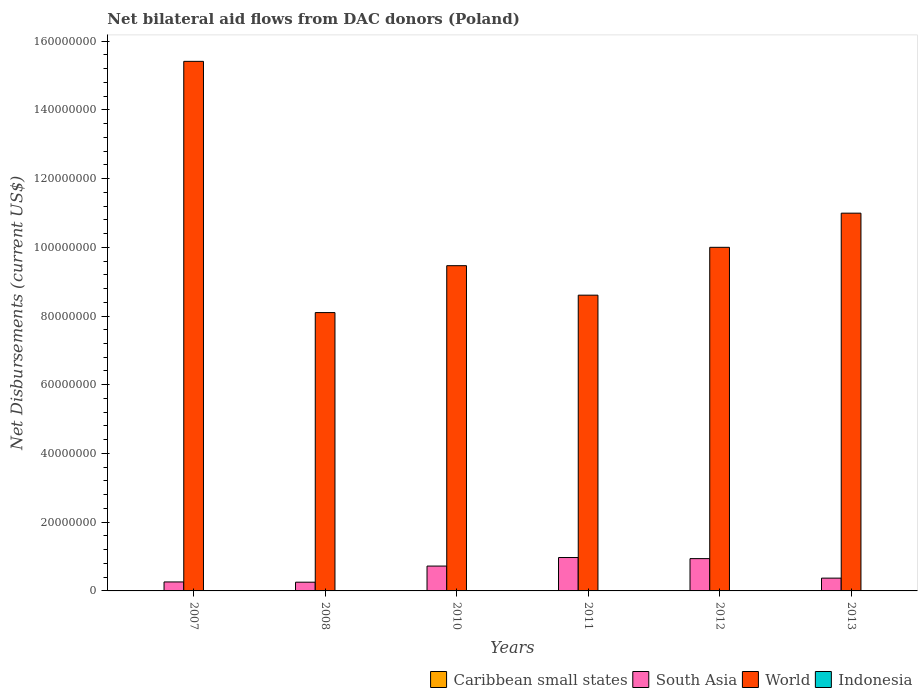How many different coloured bars are there?
Provide a short and direct response. 4. How many groups of bars are there?
Your answer should be compact. 6. What is the label of the 6th group of bars from the left?
Provide a short and direct response. 2013. What is the net bilateral aid flows in Indonesia in 2012?
Offer a terse response. 3.00e+04. Across all years, what is the minimum net bilateral aid flows in South Asia?
Your response must be concise. 2.54e+06. In which year was the net bilateral aid flows in World maximum?
Make the answer very short. 2007. In which year was the net bilateral aid flows in South Asia minimum?
Your answer should be compact. 2008. What is the total net bilateral aid flows in Indonesia in the graph?
Your answer should be compact. 2.70e+05. What is the difference between the net bilateral aid flows in World in 2008 and that in 2013?
Provide a succinct answer. -2.89e+07. What is the difference between the net bilateral aid flows in South Asia in 2011 and the net bilateral aid flows in Indonesia in 2010?
Keep it short and to the point. 9.71e+06. What is the average net bilateral aid flows in South Asia per year?
Your answer should be compact. 5.87e+06. In the year 2008, what is the difference between the net bilateral aid flows in South Asia and net bilateral aid flows in World?
Ensure brevity in your answer.  -7.85e+07. In how many years, is the net bilateral aid flows in Caribbean small states greater than 64000000 US$?
Ensure brevity in your answer.  0. What is the ratio of the net bilateral aid flows in South Asia in 2008 to that in 2013?
Provide a short and direct response. 0.68. Is the net bilateral aid flows in South Asia in 2011 less than that in 2012?
Your response must be concise. No. What is the difference between the highest and the second highest net bilateral aid flows in South Asia?
Provide a succinct answer. 3.20e+05. What is the difference between the highest and the lowest net bilateral aid flows in Caribbean small states?
Your answer should be very brief. 6.00e+04. In how many years, is the net bilateral aid flows in South Asia greater than the average net bilateral aid flows in South Asia taken over all years?
Provide a short and direct response. 3. What does the 2nd bar from the left in 2011 represents?
Keep it short and to the point. South Asia. What does the 2nd bar from the right in 2013 represents?
Your answer should be very brief. World. Is it the case that in every year, the sum of the net bilateral aid flows in South Asia and net bilateral aid flows in Caribbean small states is greater than the net bilateral aid flows in World?
Offer a very short reply. No. How many bars are there?
Your answer should be compact. 24. How many years are there in the graph?
Provide a succinct answer. 6. What is the difference between two consecutive major ticks on the Y-axis?
Provide a succinct answer. 2.00e+07. Are the values on the major ticks of Y-axis written in scientific E-notation?
Make the answer very short. No. Does the graph contain any zero values?
Your answer should be very brief. No. Does the graph contain grids?
Make the answer very short. No. How many legend labels are there?
Your response must be concise. 4. What is the title of the graph?
Give a very brief answer. Net bilateral aid flows from DAC donors (Poland). Does "Iraq" appear as one of the legend labels in the graph?
Your answer should be very brief. No. What is the label or title of the Y-axis?
Provide a succinct answer. Net Disbursements (current US$). What is the Net Disbursements (current US$) in Caribbean small states in 2007?
Provide a short and direct response. 7.00e+04. What is the Net Disbursements (current US$) in South Asia in 2007?
Keep it short and to the point. 2.61e+06. What is the Net Disbursements (current US$) of World in 2007?
Offer a very short reply. 1.54e+08. What is the Net Disbursements (current US$) of Indonesia in 2007?
Your answer should be compact. 8.00e+04. What is the Net Disbursements (current US$) of South Asia in 2008?
Your answer should be very brief. 2.54e+06. What is the Net Disbursements (current US$) in World in 2008?
Provide a succinct answer. 8.10e+07. What is the Net Disbursements (current US$) in Indonesia in 2008?
Provide a short and direct response. 8.00e+04. What is the Net Disbursements (current US$) in South Asia in 2010?
Offer a terse response. 7.23e+06. What is the Net Disbursements (current US$) in World in 2010?
Provide a short and direct response. 9.46e+07. What is the Net Disbursements (current US$) in South Asia in 2011?
Your answer should be very brief. 9.72e+06. What is the Net Disbursements (current US$) in World in 2011?
Offer a very short reply. 8.61e+07. What is the Net Disbursements (current US$) of Caribbean small states in 2012?
Make the answer very short. 3.00e+04. What is the Net Disbursements (current US$) in South Asia in 2012?
Offer a very short reply. 9.40e+06. What is the Net Disbursements (current US$) in World in 2012?
Offer a very short reply. 1.00e+08. What is the Net Disbursements (current US$) of Caribbean small states in 2013?
Provide a short and direct response. 10000. What is the Net Disbursements (current US$) in South Asia in 2013?
Keep it short and to the point. 3.72e+06. What is the Net Disbursements (current US$) in World in 2013?
Provide a succinct answer. 1.10e+08. What is the Net Disbursements (current US$) of Indonesia in 2013?
Provide a short and direct response. 4.00e+04. Across all years, what is the maximum Net Disbursements (current US$) of South Asia?
Keep it short and to the point. 9.72e+06. Across all years, what is the maximum Net Disbursements (current US$) in World?
Your response must be concise. 1.54e+08. Across all years, what is the minimum Net Disbursements (current US$) of South Asia?
Keep it short and to the point. 2.54e+06. Across all years, what is the minimum Net Disbursements (current US$) of World?
Offer a terse response. 8.10e+07. Across all years, what is the minimum Net Disbursements (current US$) of Indonesia?
Your answer should be compact. 10000. What is the total Net Disbursements (current US$) of South Asia in the graph?
Your answer should be compact. 3.52e+07. What is the total Net Disbursements (current US$) in World in the graph?
Keep it short and to the point. 6.26e+08. What is the difference between the Net Disbursements (current US$) in South Asia in 2007 and that in 2008?
Provide a succinct answer. 7.00e+04. What is the difference between the Net Disbursements (current US$) in World in 2007 and that in 2008?
Keep it short and to the point. 7.31e+07. What is the difference between the Net Disbursements (current US$) of Caribbean small states in 2007 and that in 2010?
Offer a very short reply. 6.00e+04. What is the difference between the Net Disbursements (current US$) of South Asia in 2007 and that in 2010?
Keep it short and to the point. -4.62e+06. What is the difference between the Net Disbursements (current US$) in World in 2007 and that in 2010?
Provide a succinct answer. 5.95e+07. What is the difference between the Net Disbursements (current US$) of Indonesia in 2007 and that in 2010?
Keep it short and to the point. 7.00e+04. What is the difference between the Net Disbursements (current US$) in South Asia in 2007 and that in 2011?
Offer a terse response. -7.11e+06. What is the difference between the Net Disbursements (current US$) of World in 2007 and that in 2011?
Make the answer very short. 6.80e+07. What is the difference between the Net Disbursements (current US$) in Caribbean small states in 2007 and that in 2012?
Your answer should be very brief. 4.00e+04. What is the difference between the Net Disbursements (current US$) in South Asia in 2007 and that in 2012?
Offer a terse response. -6.79e+06. What is the difference between the Net Disbursements (current US$) of World in 2007 and that in 2012?
Make the answer very short. 5.41e+07. What is the difference between the Net Disbursements (current US$) in South Asia in 2007 and that in 2013?
Your answer should be very brief. -1.11e+06. What is the difference between the Net Disbursements (current US$) in World in 2007 and that in 2013?
Your answer should be compact. 4.42e+07. What is the difference between the Net Disbursements (current US$) of Caribbean small states in 2008 and that in 2010?
Offer a very short reply. 2.00e+04. What is the difference between the Net Disbursements (current US$) of South Asia in 2008 and that in 2010?
Ensure brevity in your answer.  -4.69e+06. What is the difference between the Net Disbursements (current US$) in World in 2008 and that in 2010?
Keep it short and to the point. -1.36e+07. What is the difference between the Net Disbursements (current US$) of Indonesia in 2008 and that in 2010?
Offer a very short reply. 7.00e+04. What is the difference between the Net Disbursements (current US$) of Caribbean small states in 2008 and that in 2011?
Provide a succinct answer. 10000. What is the difference between the Net Disbursements (current US$) of South Asia in 2008 and that in 2011?
Give a very brief answer. -7.18e+06. What is the difference between the Net Disbursements (current US$) in World in 2008 and that in 2011?
Your answer should be very brief. -5.07e+06. What is the difference between the Net Disbursements (current US$) of Caribbean small states in 2008 and that in 2012?
Your response must be concise. 0. What is the difference between the Net Disbursements (current US$) in South Asia in 2008 and that in 2012?
Your answer should be very brief. -6.86e+06. What is the difference between the Net Disbursements (current US$) of World in 2008 and that in 2012?
Your answer should be compact. -1.90e+07. What is the difference between the Net Disbursements (current US$) of Indonesia in 2008 and that in 2012?
Ensure brevity in your answer.  5.00e+04. What is the difference between the Net Disbursements (current US$) of South Asia in 2008 and that in 2013?
Provide a succinct answer. -1.18e+06. What is the difference between the Net Disbursements (current US$) of World in 2008 and that in 2013?
Provide a short and direct response. -2.89e+07. What is the difference between the Net Disbursements (current US$) of Indonesia in 2008 and that in 2013?
Provide a short and direct response. 4.00e+04. What is the difference between the Net Disbursements (current US$) in South Asia in 2010 and that in 2011?
Your response must be concise. -2.49e+06. What is the difference between the Net Disbursements (current US$) in World in 2010 and that in 2011?
Provide a succinct answer. 8.58e+06. What is the difference between the Net Disbursements (current US$) of South Asia in 2010 and that in 2012?
Provide a short and direct response. -2.17e+06. What is the difference between the Net Disbursements (current US$) in World in 2010 and that in 2012?
Offer a very short reply. -5.34e+06. What is the difference between the Net Disbursements (current US$) in Indonesia in 2010 and that in 2012?
Make the answer very short. -2.00e+04. What is the difference between the Net Disbursements (current US$) in Caribbean small states in 2010 and that in 2013?
Offer a very short reply. 0. What is the difference between the Net Disbursements (current US$) of South Asia in 2010 and that in 2013?
Keep it short and to the point. 3.51e+06. What is the difference between the Net Disbursements (current US$) of World in 2010 and that in 2013?
Your answer should be compact. -1.53e+07. What is the difference between the Net Disbursements (current US$) of Caribbean small states in 2011 and that in 2012?
Provide a succinct answer. -10000. What is the difference between the Net Disbursements (current US$) of South Asia in 2011 and that in 2012?
Offer a very short reply. 3.20e+05. What is the difference between the Net Disbursements (current US$) of World in 2011 and that in 2012?
Offer a terse response. -1.39e+07. What is the difference between the Net Disbursements (current US$) of Caribbean small states in 2011 and that in 2013?
Keep it short and to the point. 10000. What is the difference between the Net Disbursements (current US$) of South Asia in 2011 and that in 2013?
Make the answer very short. 6.00e+06. What is the difference between the Net Disbursements (current US$) of World in 2011 and that in 2013?
Provide a short and direct response. -2.39e+07. What is the difference between the Net Disbursements (current US$) of Indonesia in 2011 and that in 2013?
Make the answer very short. -10000. What is the difference between the Net Disbursements (current US$) of South Asia in 2012 and that in 2013?
Make the answer very short. 5.68e+06. What is the difference between the Net Disbursements (current US$) in World in 2012 and that in 2013?
Make the answer very short. -9.94e+06. What is the difference between the Net Disbursements (current US$) in Indonesia in 2012 and that in 2013?
Provide a short and direct response. -10000. What is the difference between the Net Disbursements (current US$) of Caribbean small states in 2007 and the Net Disbursements (current US$) of South Asia in 2008?
Make the answer very short. -2.47e+06. What is the difference between the Net Disbursements (current US$) in Caribbean small states in 2007 and the Net Disbursements (current US$) in World in 2008?
Provide a short and direct response. -8.09e+07. What is the difference between the Net Disbursements (current US$) of Caribbean small states in 2007 and the Net Disbursements (current US$) of Indonesia in 2008?
Offer a very short reply. -10000. What is the difference between the Net Disbursements (current US$) in South Asia in 2007 and the Net Disbursements (current US$) in World in 2008?
Offer a very short reply. -7.84e+07. What is the difference between the Net Disbursements (current US$) of South Asia in 2007 and the Net Disbursements (current US$) of Indonesia in 2008?
Your answer should be very brief. 2.53e+06. What is the difference between the Net Disbursements (current US$) in World in 2007 and the Net Disbursements (current US$) in Indonesia in 2008?
Your answer should be compact. 1.54e+08. What is the difference between the Net Disbursements (current US$) of Caribbean small states in 2007 and the Net Disbursements (current US$) of South Asia in 2010?
Your answer should be compact. -7.16e+06. What is the difference between the Net Disbursements (current US$) in Caribbean small states in 2007 and the Net Disbursements (current US$) in World in 2010?
Your response must be concise. -9.46e+07. What is the difference between the Net Disbursements (current US$) of Caribbean small states in 2007 and the Net Disbursements (current US$) of Indonesia in 2010?
Your answer should be compact. 6.00e+04. What is the difference between the Net Disbursements (current US$) in South Asia in 2007 and the Net Disbursements (current US$) in World in 2010?
Keep it short and to the point. -9.20e+07. What is the difference between the Net Disbursements (current US$) of South Asia in 2007 and the Net Disbursements (current US$) of Indonesia in 2010?
Your response must be concise. 2.60e+06. What is the difference between the Net Disbursements (current US$) in World in 2007 and the Net Disbursements (current US$) in Indonesia in 2010?
Ensure brevity in your answer.  1.54e+08. What is the difference between the Net Disbursements (current US$) in Caribbean small states in 2007 and the Net Disbursements (current US$) in South Asia in 2011?
Keep it short and to the point. -9.65e+06. What is the difference between the Net Disbursements (current US$) of Caribbean small states in 2007 and the Net Disbursements (current US$) of World in 2011?
Your answer should be very brief. -8.60e+07. What is the difference between the Net Disbursements (current US$) of Caribbean small states in 2007 and the Net Disbursements (current US$) of Indonesia in 2011?
Make the answer very short. 4.00e+04. What is the difference between the Net Disbursements (current US$) of South Asia in 2007 and the Net Disbursements (current US$) of World in 2011?
Provide a short and direct response. -8.35e+07. What is the difference between the Net Disbursements (current US$) in South Asia in 2007 and the Net Disbursements (current US$) in Indonesia in 2011?
Your response must be concise. 2.58e+06. What is the difference between the Net Disbursements (current US$) in World in 2007 and the Net Disbursements (current US$) in Indonesia in 2011?
Make the answer very short. 1.54e+08. What is the difference between the Net Disbursements (current US$) of Caribbean small states in 2007 and the Net Disbursements (current US$) of South Asia in 2012?
Your response must be concise. -9.33e+06. What is the difference between the Net Disbursements (current US$) of Caribbean small states in 2007 and the Net Disbursements (current US$) of World in 2012?
Make the answer very short. -9.99e+07. What is the difference between the Net Disbursements (current US$) in South Asia in 2007 and the Net Disbursements (current US$) in World in 2012?
Ensure brevity in your answer.  -9.74e+07. What is the difference between the Net Disbursements (current US$) in South Asia in 2007 and the Net Disbursements (current US$) in Indonesia in 2012?
Make the answer very short. 2.58e+06. What is the difference between the Net Disbursements (current US$) in World in 2007 and the Net Disbursements (current US$) in Indonesia in 2012?
Ensure brevity in your answer.  1.54e+08. What is the difference between the Net Disbursements (current US$) in Caribbean small states in 2007 and the Net Disbursements (current US$) in South Asia in 2013?
Provide a succinct answer. -3.65e+06. What is the difference between the Net Disbursements (current US$) in Caribbean small states in 2007 and the Net Disbursements (current US$) in World in 2013?
Your answer should be compact. -1.10e+08. What is the difference between the Net Disbursements (current US$) of Caribbean small states in 2007 and the Net Disbursements (current US$) of Indonesia in 2013?
Your answer should be very brief. 3.00e+04. What is the difference between the Net Disbursements (current US$) of South Asia in 2007 and the Net Disbursements (current US$) of World in 2013?
Offer a very short reply. -1.07e+08. What is the difference between the Net Disbursements (current US$) of South Asia in 2007 and the Net Disbursements (current US$) of Indonesia in 2013?
Offer a very short reply. 2.57e+06. What is the difference between the Net Disbursements (current US$) in World in 2007 and the Net Disbursements (current US$) in Indonesia in 2013?
Your response must be concise. 1.54e+08. What is the difference between the Net Disbursements (current US$) in Caribbean small states in 2008 and the Net Disbursements (current US$) in South Asia in 2010?
Give a very brief answer. -7.20e+06. What is the difference between the Net Disbursements (current US$) of Caribbean small states in 2008 and the Net Disbursements (current US$) of World in 2010?
Offer a very short reply. -9.46e+07. What is the difference between the Net Disbursements (current US$) of Caribbean small states in 2008 and the Net Disbursements (current US$) of Indonesia in 2010?
Offer a very short reply. 2.00e+04. What is the difference between the Net Disbursements (current US$) in South Asia in 2008 and the Net Disbursements (current US$) in World in 2010?
Make the answer very short. -9.21e+07. What is the difference between the Net Disbursements (current US$) in South Asia in 2008 and the Net Disbursements (current US$) in Indonesia in 2010?
Give a very brief answer. 2.53e+06. What is the difference between the Net Disbursements (current US$) of World in 2008 and the Net Disbursements (current US$) of Indonesia in 2010?
Offer a very short reply. 8.10e+07. What is the difference between the Net Disbursements (current US$) of Caribbean small states in 2008 and the Net Disbursements (current US$) of South Asia in 2011?
Your answer should be very brief. -9.69e+06. What is the difference between the Net Disbursements (current US$) in Caribbean small states in 2008 and the Net Disbursements (current US$) in World in 2011?
Your answer should be very brief. -8.60e+07. What is the difference between the Net Disbursements (current US$) in Caribbean small states in 2008 and the Net Disbursements (current US$) in Indonesia in 2011?
Your answer should be very brief. 0. What is the difference between the Net Disbursements (current US$) of South Asia in 2008 and the Net Disbursements (current US$) of World in 2011?
Your response must be concise. -8.35e+07. What is the difference between the Net Disbursements (current US$) of South Asia in 2008 and the Net Disbursements (current US$) of Indonesia in 2011?
Ensure brevity in your answer.  2.51e+06. What is the difference between the Net Disbursements (current US$) of World in 2008 and the Net Disbursements (current US$) of Indonesia in 2011?
Offer a very short reply. 8.10e+07. What is the difference between the Net Disbursements (current US$) of Caribbean small states in 2008 and the Net Disbursements (current US$) of South Asia in 2012?
Your response must be concise. -9.37e+06. What is the difference between the Net Disbursements (current US$) of Caribbean small states in 2008 and the Net Disbursements (current US$) of World in 2012?
Make the answer very short. -1.00e+08. What is the difference between the Net Disbursements (current US$) in Caribbean small states in 2008 and the Net Disbursements (current US$) in Indonesia in 2012?
Your answer should be compact. 0. What is the difference between the Net Disbursements (current US$) in South Asia in 2008 and the Net Disbursements (current US$) in World in 2012?
Offer a very short reply. -9.74e+07. What is the difference between the Net Disbursements (current US$) of South Asia in 2008 and the Net Disbursements (current US$) of Indonesia in 2012?
Provide a short and direct response. 2.51e+06. What is the difference between the Net Disbursements (current US$) in World in 2008 and the Net Disbursements (current US$) in Indonesia in 2012?
Make the answer very short. 8.10e+07. What is the difference between the Net Disbursements (current US$) in Caribbean small states in 2008 and the Net Disbursements (current US$) in South Asia in 2013?
Ensure brevity in your answer.  -3.69e+06. What is the difference between the Net Disbursements (current US$) of Caribbean small states in 2008 and the Net Disbursements (current US$) of World in 2013?
Your answer should be very brief. -1.10e+08. What is the difference between the Net Disbursements (current US$) of South Asia in 2008 and the Net Disbursements (current US$) of World in 2013?
Your answer should be compact. -1.07e+08. What is the difference between the Net Disbursements (current US$) of South Asia in 2008 and the Net Disbursements (current US$) of Indonesia in 2013?
Provide a short and direct response. 2.50e+06. What is the difference between the Net Disbursements (current US$) in World in 2008 and the Net Disbursements (current US$) in Indonesia in 2013?
Give a very brief answer. 8.10e+07. What is the difference between the Net Disbursements (current US$) in Caribbean small states in 2010 and the Net Disbursements (current US$) in South Asia in 2011?
Offer a very short reply. -9.71e+06. What is the difference between the Net Disbursements (current US$) of Caribbean small states in 2010 and the Net Disbursements (current US$) of World in 2011?
Ensure brevity in your answer.  -8.61e+07. What is the difference between the Net Disbursements (current US$) of Caribbean small states in 2010 and the Net Disbursements (current US$) of Indonesia in 2011?
Give a very brief answer. -2.00e+04. What is the difference between the Net Disbursements (current US$) of South Asia in 2010 and the Net Disbursements (current US$) of World in 2011?
Your answer should be very brief. -7.88e+07. What is the difference between the Net Disbursements (current US$) in South Asia in 2010 and the Net Disbursements (current US$) in Indonesia in 2011?
Give a very brief answer. 7.20e+06. What is the difference between the Net Disbursements (current US$) of World in 2010 and the Net Disbursements (current US$) of Indonesia in 2011?
Provide a succinct answer. 9.46e+07. What is the difference between the Net Disbursements (current US$) in Caribbean small states in 2010 and the Net Disbursements (current US$) in South Asia in 2012?
Your answer should be very brief. -9.39e+06. What is the difference between the Net Disbursements (current US$) in Caribbean small states in 2010 and the Net Disbursements (current US$) in World in 2012?
Keep it short and to the point. -1.00e+08. What is the difference between the Net Disbursements (current US$) in South Asia in 2010 and the Net Disbursements (current US$) in World in 2012?
Ensure brevity in your answer.  -9.28e+07. What is the difference between the Net Disbursements (current US$) in South Asia in 2010 and the Net Disbursements (current US$) in Indonesia in 2012?
Ensure brevity in your answer.  7.20e+06. What is the difference between the Net Disbursements (current US$) in World in 2010 and the Net Disbursements (current US$) in Indonesia in 2012?
Keep it short and to the point. 9.46e+07. What is the difference between the Net Disbursements (current US$) in Caribbean small states in 2010 and the Net Disbursements (current US$) in South Asia in 2013?
Offer a terse response. -3.71e+06. What is the difference between the Net Disbursements (current US$) in Caribbean small states in 2010 and the Net Disbursements (current US$) in World in 2013?
Keep it short and to the point. -1.10e+08. What is the difference between the Net Disbursements (current US$) of South Asia in 2010 and the Net Disbursements (current US$) of World in 2013?
Keep it short and to the point. -1.03e+08. What is the difference between the Net Disbursements (current US$) in South Asia in 2010 and the Net Disbursements (current US$) in Indonesia in 2013?
Ensure brevity in your answer.  7.19e+06. What is the difference between the Net Disbursements (current US$) of World in 2010 and the Net Disbursements (current US$) of Indonesia in 2013?
Ensure brevity in your answer.  9.46e+07. What is the difference between the Net Disbursements (current US$) in Caribbean small states in 2011 and the Net Disbursements (current US$) in South Asia in 2012?
Provide a succinct answer. -9.38e+06. What is the difference between the Net Disbursements (current US$) of Caribbean small states in 2011 and the Net Disbursements (current US$) of World in 2012?
Give a very brief answer. -1.00e+08. What is the difference between the Net Disbursements (current US$) in Caribbean small states in 2011 and the Net Disbursements (current US$) in Indonesia in 2012?
Offer a very short reply. -10000. What is the difference between the Net Disbursements (current US$) of South Asia in 2011 and the Net Disbursements (current US$) of World in 2012?
Offer a very short reply. -9.03e+07. What is the difference between the Net Disbursements (current US$) of South Asia in 2011 and the Net Disbursements (current US$) of Indonesia in 2012?
Your answer should be very brief. 9.69e+06. What is the difference between the Net Disbursements (current US$) in World in 2011 and the Net Disbursements (current US$) in Indonesia in 2012?
Provide a succinct answer. 8.60e+07. What is the difference between the Net Disbursements (current US$) in Caribbean small states in 2011 and the Net Disbursements (current US$) in South Asia in 2013?
Give a very brief answer. -3.70e+06. What is the difference between the Net Disbursements (current US$) in Caribbean small states in 2011 and the Net Disbursements (current US$) in World in 2013?
Make the answer very short. -1.10e+08. What is the difference between the Net Disbursements (current US$) of South Asia in 2011 and the Net Disbursements (current US$) of World in 2013?
Offer a terse response. -1.00e+08. What is the difference between the Net Disbursements (current US$) in South Asia in 2011 and the Net Disbursements (current US$) in Indonesia in 2013?
Give a very brief answer. 9.68e+06. What is the difference between the Net Disbursements (current US$) in World in 2011 and the Net Disbursements (current US$) in Indonesia in 2013?
Offer a very short reply. 8.60e+07. What is the difference between the Net Disbursements (current US$) of Caribbean small states in 2012 and the Net Disbursements (current US$) of South Asia in 2013?
Your answer should be very brief. -3.69e+06. What is the difference between the Net Disbursements (current US$) in Caribbean small states in 2012 and the Net Disbursements (current US$) in World in 2013?
Give a very brief answer. -1.10e+08. What is the difference between the Net Disbursements (current US$) of Caribbean small states in 2012 and the Net Disbursements (current US$) of Indonesia in 2013?
Your answer should be very brief. -10000. What is the difference between the Net Disbursements (current US$) of South Asia in 2012 and the Net Disbursements (current US$) of World in 2013?
Ensure brevity in your answer.  -1.01e+08. What is the difference between the Net Disbursements (current US$) of South Asia in 2012 and the Net Disbursements (current US$) of Indonesia in 2013?
Your answer should be very brief. 9.36e+06. What is the difference between the Net Disbursements (current US$) in World in 2012 and the Net Disbursements (current US$) in Indonesia in 2013?
Ensure brevity in your answer.  1.00e+08. What is the average Net Disbursements (current US$) of Caribbean small states per year?
Offer a terse response. 2.83e+04. What is the average Net Disbursements (current US$) of South Asia per year?
Offer a terse response. 5.87e+06. What is the average Net Disbursements (current US$) of World per year?
Offer a terse response. 1.04e+08. What is the average Net Disbursements (current US$) in Indonesia per year?
Offer a terse response. 4.50e+04. In the year 2007, what is the difference between the Net Disbursements (current US$) of Caribbean small states and Net Disbursements (current US$) of South Asia?
Your response must be concise. -2.54e+06. In the year 2007, what is the difference between the Net Disbursements (current US$) in Caribbean small states and Net Disbursements (current US$) in World?
Keep it short and to the point. -1.54e+08. In the year 2007, what is the difference between the Net Disbursements (current US$) of Caribbean small states and Net Disbursements (current US$) of Indonesia?
Offer a terse response. -10000. In the year 2007, what is the difference between the Net Disbursements (current US$) of South Asia and Net Disbursements (current US$) of World?
Provide a succinct answer. -1.52e+08. In the year 2007, what is the difference between the Net Disbursements (current US$) of South Asia and Net Disbursements (current US$) of Indonesia?
Offer a terse response. 2.53e+06. In the year 2007, what is the difference between the Net Disbursements (current US$) of World and Net Disbursements (current US$) of Indonesia?
Make the answer very short. 1.54e+08. In the year 2008, what is the difference between the Net Disbursements (current US$) in Caribbean small states and Net Disbursements (current US$) in South Asia?
Give a very brief answer. -2.51e+06. In the year 2008, what is the difference between the Net Disbursements (current US$) in Caribbean small states and Net Disbursements (current US$) in World?
Offer a terse response. -8.10e+07. In the year 2008, what is the difference between the Net Disbursements (current US$) of Caribbean small states and Net Disbursements (current US$) of Indonesia?
Provide a succinct answer. -5.00e+04. In the year 2008, what is the difference between the Net Disbursements (current US$) in South Asia and Net Disbursements (current US$) in World?
Ensure brevity in your answer.  -7.85e+07. In the year 2008, what is the difference between the Net Disbursements (current US$) of South Asia and Net Disbursements (current US$) of Indonesia?
Provide a short and direct response. 2.46e+06. In the year 2008, what is the difference between the Net Disbursements (current US$) in World and Net Disbursements (current US$) in Indonesia?
Provide a succinct answer. 8.09e+07. In the year 2010, what is the difference between the Net Disbursements (current US$) in Caribbean small states and Net Disbursements (current US$) in South Asia?
Give a very brief answer. -7.22e+06. In the year 2010, what is the difference between the Net Disbursements (current US$) of Caribbean small states and Net Disbursements (current US$) of World?
Give a very brief answer. -9.46e+07. In the year 2010, what is the difference between the Net Disbursements (current US$) of South Asia and Net Disbursements (current US$) of World?
Provide a succinct answer. -8.74e+07. In the year 2010, what is the difference between the Net Disbursements (current US$) in South Asia and Net Disbursements (current US$) in Indonesia?
Your response must be concise. 7.22e+06. In the year 2010, what is the difference between the Net Disbursements (current US$) of World and Net Disbursements (current US$) of Indonesia?
Offer a very short reply. 9.46e+07. In the year 2011, what is the difference between the Net Disbursements (current US$) in Caribbean small states and Net Disbursements (current US$) in South Asia?
Offer a very short reply. -9.70e+06. In the year 2011, what is the difference between the Net Disbursements (current US$) of Caribbean small states and Net Disbursements (current US$) of World?
Your answer should be compact. -8.60e+07. In the year 2011, what is the difference between the Net Disbursements (current US$) of Caribbean small states and Net Disbursements (current US$) of Indonesia?
Offer a terse response. -10000. In the year 2011, what is the difference between the Net Disbursements (current US$) in South Asia and Net Disbursements (current US$) in World?
Provide a succinct answer. -7.64e+07. In the year 2011, what is the difference between the Net Disbursements (current US$) in South Asia and Net Disbursements (current US$) in Indonesia?
Ensure brevity in your answer.  9.69e+06. In the year 2011, what is the difference between the Net Disbursements (current US$) of World and Net Disbursements (current US$) of Indonesia?
Your answer should be compact. 8.60e+07. In the year 2012, what is the difference between the Net Disbursements (current US$) of Caribbean small states and Net Disbursements (current US$) of South Asia?
Ensure brevity in your answer.  -9.37e+06. In the year 2012, what is the difference between the Net Disbursements (current US$) of Caribbean small states and Net Disbursements (current US$) of World?
Your answer should be very brief. -1.00e+08. In the year 2012, what is the difference between the Net Disbursements (current US$) in South Asia and Net Disbursements (current US$) in World?
Keep it short and to the point. -9.06e+07. In the year 2012, what is the difference between the Net Disbursements (current US$) in South Asia and Net Disbursements (current US$) in Indonesia?
Make the answer very short. 9.37e+06. In the year 2012, what is the difference between the Net Disbursements (current US$) in World and Net Disbursements (current US$) in Indonesia?
Your answer should be compact. 1.00e+08. In the year 2013, what is the difference between the Net Disbursements (current US$) in Caribbean small states and Net Disbursements (current US$) in South Asia?
Make the answer very short. -3.71e+06. In the year 2013, what is the difference between the Net Disbursements (current US$) of Caribbean small states and Net Disbursements (current US$) of World?
Make the answer very short. -1.10e+08. In the year 2013, what is the difference between the Net Disbursements (current US$) in Caribbean small states and Net Disbursements (current US$) in Indonesia?
Provide a succinct answer. -3.00e+04. In the year 2013, what is the difference between the Net Disbursements (current US$) of South Asia and Net Disbursements (current US$) of World?
Ensure brevity in your answer.  -1.06e+08. In the year 2013, what is the difference between the Net Disbursements (current US$) of South Asia and Net Disbursements (current US$) of Indonesia?
Offer a terse response. 3.68e+06. In the year 2013, what is the difference between the Net Disbursements (current US$) in World and Net Disbursements (current US$) in Indonesia?
Provide a short and direct response. 1.10e+08. What is the ratio of the Net Disbursements (current US$) of Caribbean small states in 2007 to that in 2008?
Provide a succinct answer. 2.33. What is the ratio of the Net Disbursements (current US$) of South Asia in 2007 to that in 2008?
Offer a very short reply. 1.03. What is the ratio of the Net Disbursements (current US$) of World in 2007 to that in 2008?
Provide a short and direct response. 1.9. What is the ratio of the Net Disbursements (current US$) of Caribbean small states in 2007 to that in 2010?
Offer a very short reply. 7. What is the ratio of the Net Disbursements (current US$) of South Asia in 2007 to that in 2010?
Give a very brief answer. 0.36. What is the ratio of the Net Disbursements (current US$) in World in 2007 to that in 2010?
Give a very brief answer. 1.63. What is the ratio of the Net Disbursements (current US$) in Indonesia in 2007 to that in 2010?
Ensure brevity in your answer.  8. What is the ratio of the Net Disbursements (current US$) of Caribbean small states in 2007 to that in 2011?
Ensure brevity in your answer.  3.5. What is the ratio of the Net Disbursements (current US$) of South Asia in 2007 to that in 2011?
Make the answer very short. 0.27. What is the ratio of the Net Disbursements (current US$) of World in 2007 to that in 2011?
Keep it short and to the point. 1.79. What is the ratio of the Net Disbursements (current US$) of Indonesia in 2007 to that in 2011?
Your response must be concise. 2.67. What is the ratio of the Net Disbursements (current US$) in Caribbean small states in 2007 to that in 2012?
Offer a terse response. 2.33. What is the ratio of the Net Disbursements (current US$) of South Asia in 2007 to that in 2012?
Your response must be concise. 0.28. What is the ratio of the Net Disbursements (current US$) in World in 2007 to that in 2012?
Your response must be concise. 1.54. What is the ratio of the Net Disbursements (current US$) in Indonesia in 2007 to that in 2012?
Keep it short and to the point. 2.67. What is the ratio of the Net Disbursements (current US$) of South Asia in 2007 to that in 2013?
Your answer should be compact. 0.7. What is the ratio of the Net Disbursements (current US$) in World in 2007 to that in 2013?
Give a very brief answer. 1.4. What is the ratio of the Net Disbursements (current US$) in Indonesia in 2007 to that in 2013?
Offer a very short reply. 2. What is the ratio of the Net Disbursements (current US$) in South Asia in 2008 to that in 2010?
Your answer should be very brief. 0.35. What is the ratio of the Net Disbursements (current US$) in World in 2008 to that in 2010?
Your answer should be compact. 0.86. What is the ratio of the Net Disbursements (current US$) of Indonesia in 2008 to that in 2010?
Give a very brief answer. 8. What is the ratio of the Net Disbursements (current US$) in South Asia in 2008 to that in 2011?
Provide a short and direct response. 0.26. What is the ratio of the Net Disbursements (current US$) of World in 2008 to that in 2011?
Your response must be concise. 0.94. What is the ratio of the Net Disbursements (current US$) in Indonesia in 2008 to that in 2011?
Keep it short and to the point. 2.67. What is the ratio of the Net Disbursements (current US$) of Caribbean small states in 2008 to that in 2012?
Keep it short and to the point. 1. What is the ratio of the Net Disbursements (current US$) in South Asia in 2008 to that in 2012?
Make the answer very short. 0.27. What is the ratio of the Net Disbursements (current US$) in World in 2008 to that in 2012?
Ensure brevity in your answer.  0.81. What is the ratio of the Net Disbursements (current US$) of Indonesia in 2008 to that in 2012?
Make the answer very short. 2.67. What is the ratio of the Net Disbursements (current US$) of Caribbean small states in 2008 to that in 2013?
Provide a short and direct response. 3. What is the ratio of the Net Disbursements (current US$) of South Asia in 2008 to that in 2013?
Keep it short and to the point. 0.68. What is the ratio of the Net Disbursements (current US$) in World in 2008 to that in 2013?
Keep it short and to the point. 0.74. What is the ratio of the Net Disbursements (current US$) in Indonesia in 2008 to that in 2013?
Your answer should be compact. 2. What is the ratio of the Net Disbursements (current US$) in South Asia in 2010 to that in 2011?
Make the answer very short. 0.74. What is the ratio of the Net Disbursements (current US$) of World in 2010 to that in 2011?
Offer a terse response. 1.1. What is the ratio of the Net Disbursements (current US$) in South Asia in 2010 to that in 2012?
Your response must be concise. 0.77. What is the ratio of the Net Disbursements (current US$) of World in 2010 to that in 2012?
Provide a short and direct response. 0.95. What is the ratio of the Net Disbursements (current US$) in Indonesia in 2010 to that in 2012?
Keep it short and to the point. 0.33. What is the ratio of the Net Disbursements (current US$) in Caribbean small states in 2010 to that in 2013?
Provide a short and direct response. 1. What is the ratio of the Net Disbursements (current US$) of South Asia in 2010 to that in 2013?
Your answer should be very brief. 1.94. What is the ratio of the Net Disbursements (current US$) in World in 2010 to that in 2013?
Provide a short and direct response. 0.86. What is the ratio of the Net Disbursements (current US$) in Indonesia in 2010 to that in 2013?
Provide a short and direct response. 0.25. What is the ratio of the Net Disbursements (current US$) of Caribbean small states in 2011 to that in 2012?
Give a very brief answer. 0.67. What is the ratio of the Net Disbursements (current US$) in South Asia in 2011 to that in 2012?
Make the answer very short. 1.03. What is the ratio of the Net Disbursements (current US$) in World in 2011 to that in 2012?
Ensure brevity in your answer.  0.86. What is the ratio of the Net Disbursements (current US$) of Caribbean small states in 2011 to that in 2013?
Offer a very short reply. 2. What is the ratio of the Net Disbursements (current US$) in South Asia in 2011 to that in 2013?
Keep it short and to the point. 2.61. What is the ratio of the Net Disbursements (current US$) in World in 2011 to that in 2013?
Your response must be concise. 0.78. What is the ratio of the Net Disbursements (current US$) of South Asia in 2012 to that in 2013?
Your response must be concise. 2.53. What is the ratio of the Net Disbursements (current US$) in World in 2012 to that in 2013?
Provide a short and direct response. 0.91. What is the ratio of the Net Disbursements (current US$) of Indonesia in 2012 to that in 2013?
Your answer should be very brief. 0.75. What is the difference between the highest and the second highest Net Disbursements (current US$) in Caribbean small states?
Your answer should be very brief. 4.00e+04. What is the difference between the highest and the second highest Net Disbursements (current US$) of South Asia?
Provide a short and direct response. 3.20e+05. What is the difference between the highest and the second highest Net Disbursements (current US$) in World?
Your response must be concise. 4.42e+07. What is the difference between the highest and the lowest Net Disbursements (current US$) in South Asia?
Ensure brevity in your answer.  7.18e+06. What is the difference between the highest and the lowest Net Disbursements (current US$) of World?
Your answer should be very brief. 7.31e+07. What is the difference between the highest and the lowest Net Disbursements (current US$) in Indonesia?
Provide a succinct answer. 7.00e+04. 